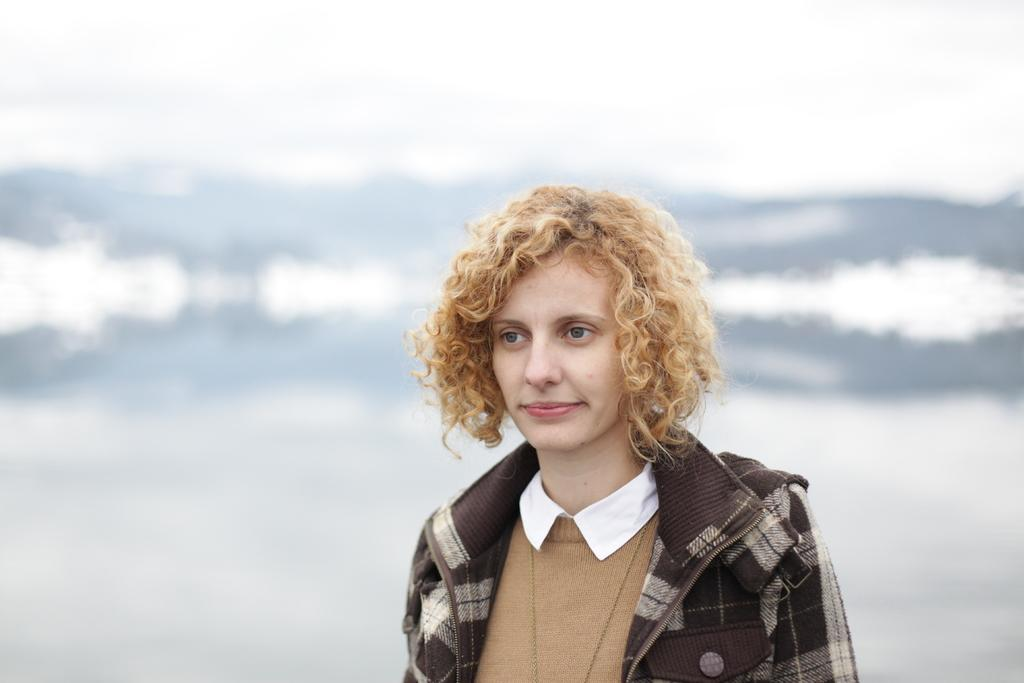Who is the main subject in the image? There is a woman in the image. What is the woman wearing? The woman is wearing a jacket and a t-shirt. What is the woman's facial expression in the image? The woman is smiling. How would you describe the background of the image? The background of the image is blurred. What type of whip can be seen in the woman's hand in the image? There is no whip present in the image; the woman is not holding any object. 